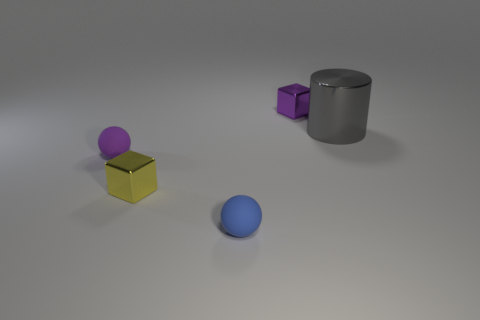Add 4 green spheres. How many objects exist? 9 Subtract all blocks. How many objects are left? 3 Subtract all small blue spheres. Subtract all green metal things. How many objects are left? 4 Add 5 large gray things. How many large gray things are left? 6 Add 4 large brown metallic things. How many large brown metallic things exist? 4 Subtract 0 yellow spheres. How many objects are left? 5 